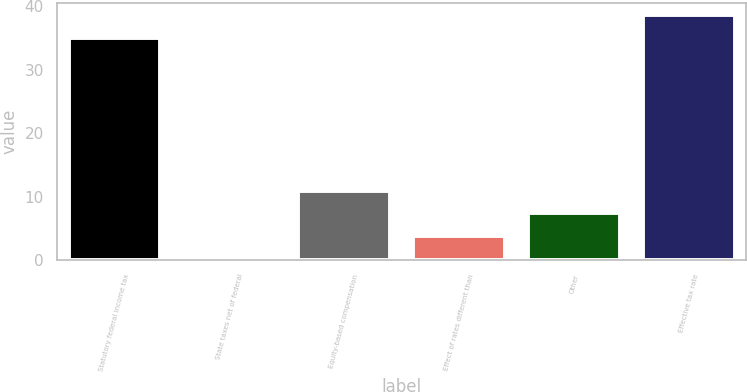Convert chart to OTSL. <chart><loc_0><loc_0><loc_500><loc_500><bar_chart><fcel>Statutory federal income tax<fcel>State taxes net of federal<fcel>Equity-based compensation<fcel>Effect of rates different than<fcel>Other<fcel>Effective tax rate<nl><fcel>35<fcel>0.2<fcel>10.94<fcel>3.78<fcel>7.36<fcel>38.58<nl></chart> 